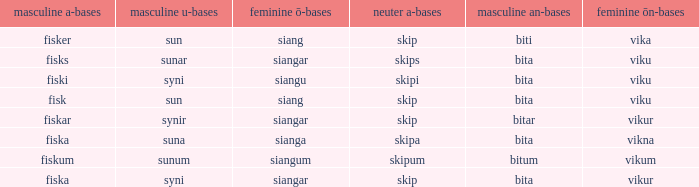What is the u form of the word with a neuter form of skip and a masculine a-ending of fisker? Sun. 